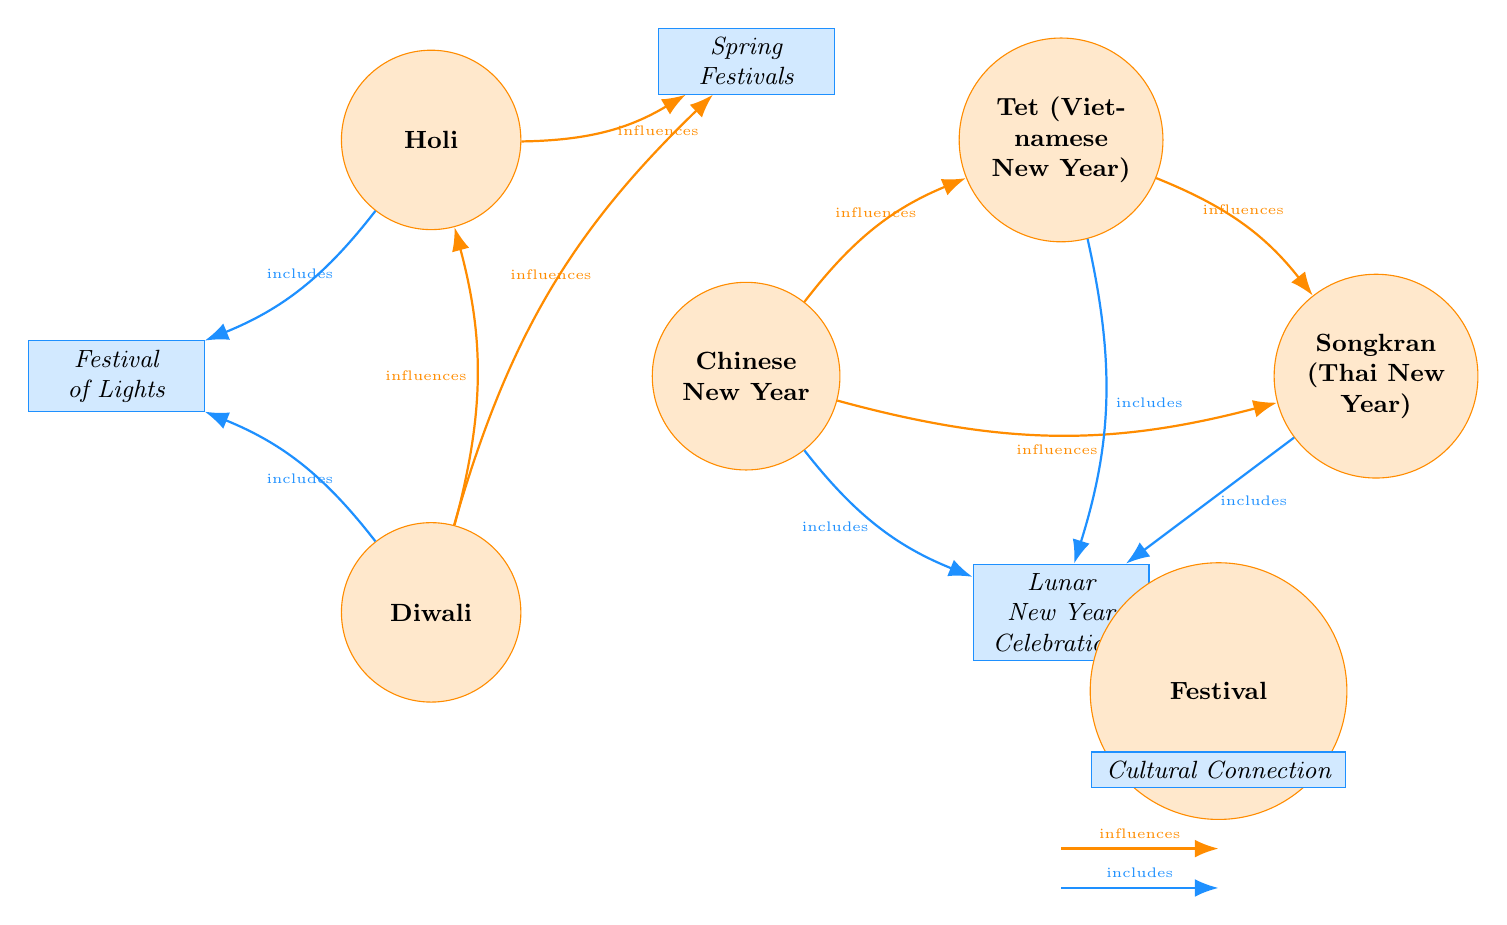What festivals influence Tet (Vietnamese New Year)? The diagram shows an edge labeled "influences" from Chinese New Year to Tet and from Diwali to Tet. Therefore, it can be concluded that the festivals that influence Tet are Chinese New Year and Diwali.
Answer: Chinese New Year, Diwali How many cultural connections are represented in the diagram? The diagram features four nodes categorized as cultural connections: Lunar New Year Celebrations, Festival of Lights, and Spring Festivals. Therefore, the total count of cultural connection nodes is three.
Answer: 3 What festival influences Songkran (Thai New Year)? The diagram shows an edge labeled "influences" from both Chinese New Year and Tet to Songkran. Hence, the influencing festivals are Chinese New Year and Tet.
Answer: Chinese New Year, Tet Which festival includes Lunar New Year Celebrations? The diagram indicates that Chinese New Year, Tet (Vietnamese New Year), and Songkran (Thai New Year) all have edges labeled "includes" connecting them to Lunar New Year Celebrations. Therefore, the festivals that include Lunar New Year Celebrations are three.
Answer: Chinese New Year, Tet (Vietnamese New Year), Songkran (Thai New Year) What is the relationship between Diwali and Holi? The diagram features a link labeled "influences" from Diwali to Holi, indicating that Diwali influences Holi. Thus, the specific relationship is a direct influence.
Answer: influences How many total edges are present in the diagram? To find the total number of edges, we count all the connections; there are 10 edges in total based on the connections represented in the diagram.
Answer: 10 Which festival has the most connections to other festivals? By analyzing the diagram, Diwali has three outgoing edges influencing both Holi and Spring Festivals and including Festival of Lights. This makes Diwali the festival with the most connections to other festivals.
Answer: Diwali What type of connection is present between Holi and the Festival of Lights? The diagram illustrates an edge labeled "includes" between Holi and Festival of Lights, indicating that Holi is associated with the cultural connection known as Festival of Lights.
Answer: includes 